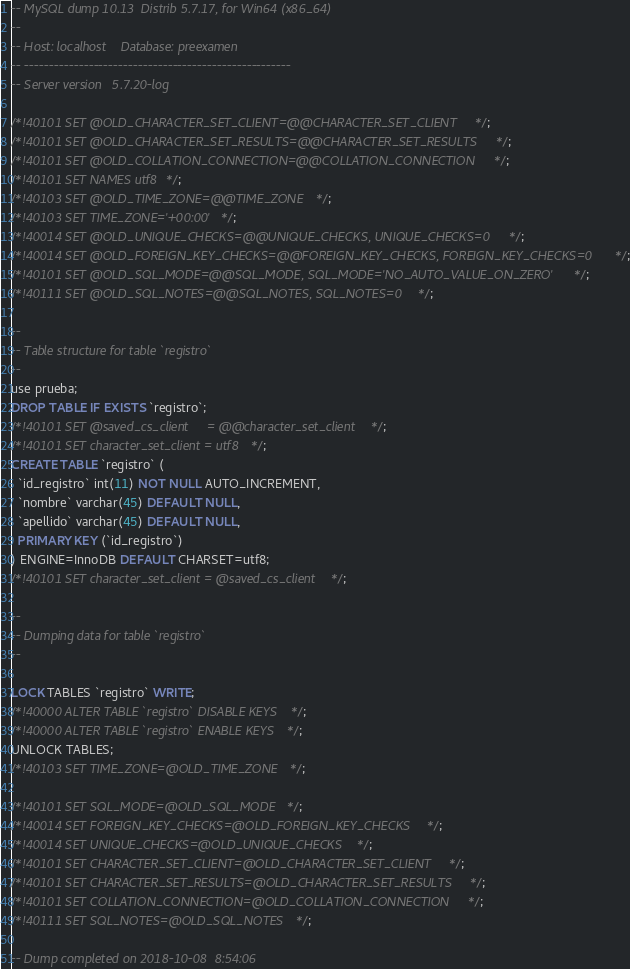Convert code to text. <code><loc_0><loc_0><loc_500><loc_500><_SQL_>-- MySQL dump 10.13  Distrib 5.7.17, for Win64 (x86_64)
--
-- Host: localhost    Database: preexamen
-- ------------------------------------------------------
-- Server version	5.7.20-log

/*!40101 SET @OLD_CHARACTER_SET_CLIENT=@@CHARACTER_SET_CLIENT */;
/*!40101 SET @OLD_CHARACTER_SET_RESULTS=@@CHARACTER_SET_RESULTS */;
/*!40101 SET @OLD_COLLATION_CONNECTION=@@COLLATION_CONNECTION */;
/*!40101 SET NAMES utf8 */;
/*!40103 SET @OLD_TIME_ZONE=@@TIME_ZONE */;
/*!40103 SET TIME_ZONE='+00:00' */;
/*!40014 SET @OLD_UNIQUE_CHECKS=@@UNIQUE_CHECKS, UNIQUE_CHECKS=0 */;
/*!40014 SET @OLD_FOREIGN_KEY_CHECKS=@@FOREIGN_KEY_CHECKS, FOREIGN_KEY_CHECKS=0 */;
/*!40101 SET @OLD_SQL_MODE=@@SQL_MODE, SQL_MODE='NO_AUTO_VALUE_ON_ZERO' */;
/*!40111 SET @OLD_SQL_NOTES=@@SQL_NOTES, SQL_NOTES=0 */;

--
-- Table structure for table `registro`
--
use prueba;
DROP TABLE IF EXISTS `registro`;
/*!40101 SET @saved_cs_client     = @@character_set_client */;
/*!40101 SET character_set_client = utf8 */;
CREATE TABLE `registro` (
  `id_registro` int(11) NOT NULL AUTO_INCREMENT,
  `nombre` varchar(45) DEFAULT NULL,
  `apellido` varchar(45) DEFAULT NULL,
  PRIMARY KEY (`id_registro`)
) ENGINE=InnoDB DEFAULT CHARSET=utf8;
/*!40101 SET character_set_client = @saved_cs_client */;

--
-- Dumping data for table `registro`
--

LOCK TABLES `registro` WRITE;
/*!40000 ALTER TABLE `registro` DISABLE KEYS */;
/*!40000 ALTER TABLE `registro` ENABLE KEYS */;
UNLOCK TABLES;
/*!40103 SET TIME_ZONE=@OLD_TIME_ZONE */;

/*!40101 SET SQL_MODE=@OLD_SQL_MODE */;
/*!40014 SET FOREIGN_KEY_CHECKS=@OLD_FOREIGN_KEY_CHECKS */;
/*!40014 SET UNIQUE_CHECKS=@OLD_UNIQUE_CHECKS */;
/*!40101 SET CHARACTER_SET_CLIENT=@OLD_CHARACTER_SET_CLIENT */;
/*!40101 SET CHARACTER_SET_RESULTS=@OLD_CHARACTER_SET_RESULTS */;
/*!40101 SET COLLATION_CONNECTION=@OLD_COLLATION_CONNECTION */;
/*!40111 SET SQL_NOTES=@OLD_SQL_NOTES */;

-- Dump completed on 2018-10-08  8:54:06
</code> 